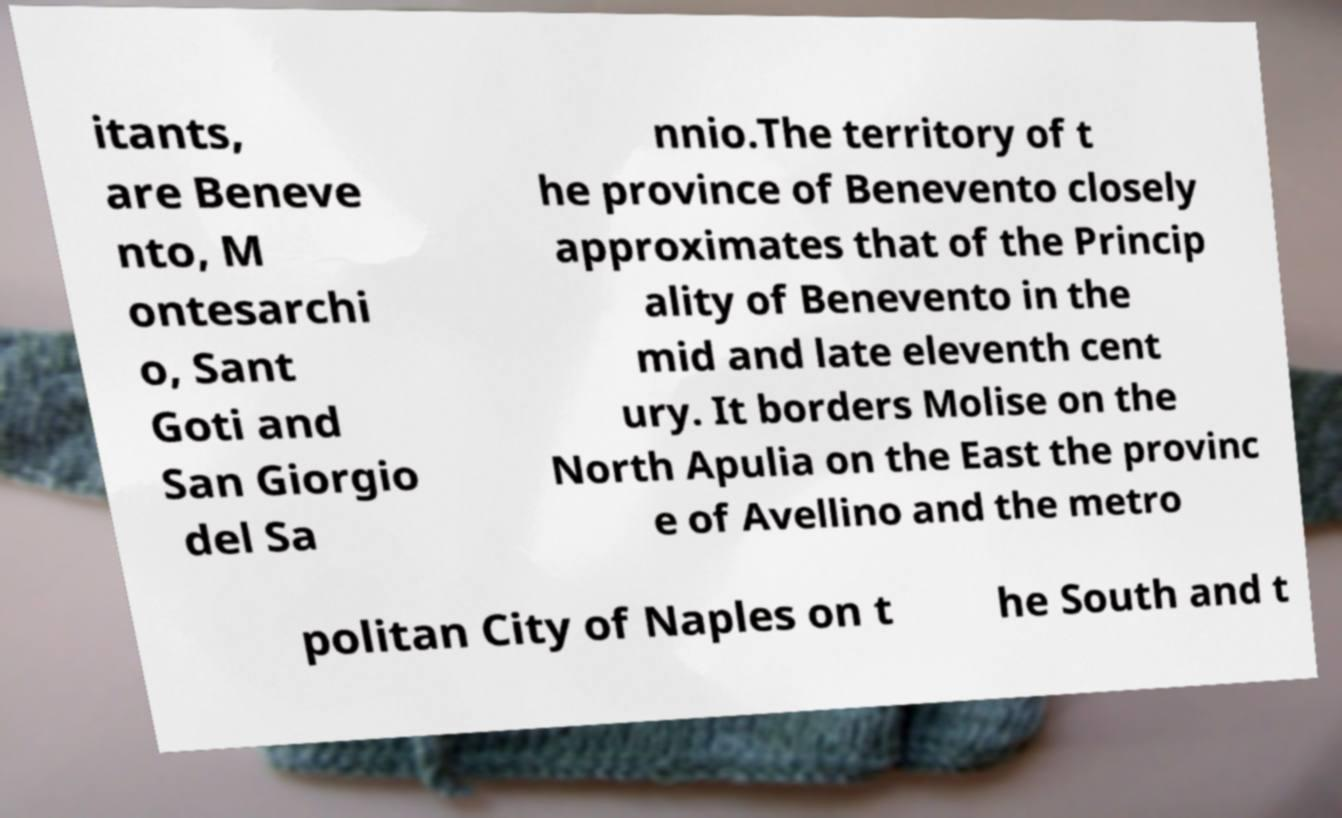For documentation purposes, I need the text within this image transcribed. Could you provide that? itants, are Beneve nto, M ontesarchi o, Sant Goti and San Giorgio del Sa nnio.The territory of t he province of Benevento closely approximates that of the Princip ality of Benevento in the mid and late eleventh cent ury. It borders Molise on the North Apulia on the East the provinc e of Avellino and the metro politan City of Naples on t he South and t 